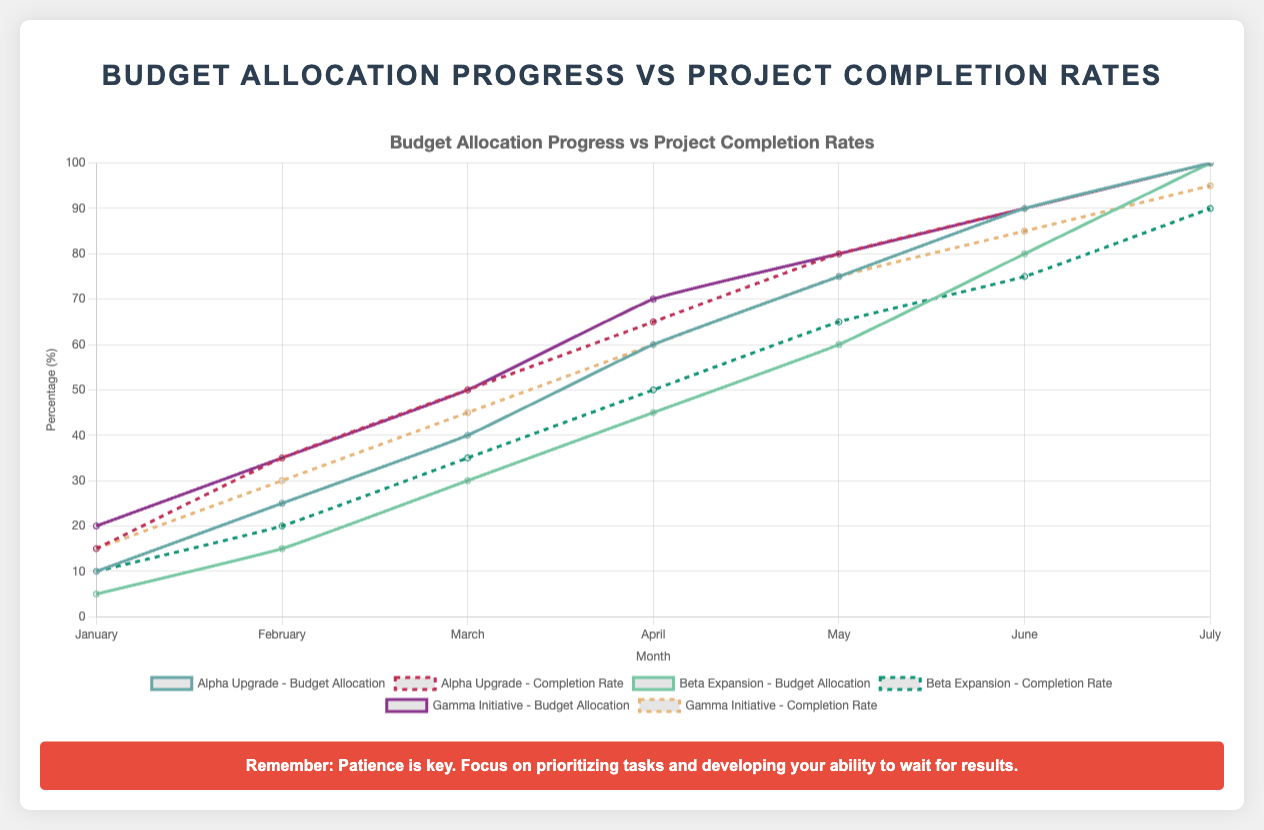Which project has the highest completion rate in July? To find the project with the highest completion rate in July, locate the "July" data points for all projects and compare their completion rates: Alpha Upgrade (100%), Beta Expansion (90%), Gamma Initiative (95%). Thus, Alpha Upgrade has the highest completion rate in July.
Answer: Alpha Upgrade Which month has the largest difference between budget allocation and completion rate for Beta Expansion? Look at the differences between budget allocation and completion rate for Beta Expansion in each month: January (5%), February (5%), March (5%), April (5%), May (5%), June (5%), and July (10%). July shows the largest difference of 10%.
Answer: July Compare the budget allocation progress for Alpha Upgrade and Beta Expansion in March. Which one is higher and by how much? Check the budget allocation for both projects in March: Alpha Upgrade (40%) and Beta Expansion (30%). The difference is 40% - 30% = 10%. Alpha Upgrade has a higher budget allocation progress by 10%.
Answer: Alpha Upgrade by 10% Calculate the average completion rate in May across all projects. Add the completion rates for May: Alpha Upgrade (80%), Beta Expansion (65%), and Gamma Initiative (75%). The average is (80 + 65 + 75) / 3 = 73.33%.
Answer: 73.33% In which month does Gamma Initiative achieve a higher completion rate than its budget allocation? Compare the budget allocation and completion rate for Gamma Initiative for each month: January, February, March, April, May, June, and July. Only in July is the completion rate (95%) higher than the budget allocation (90%).
Answer: July Between Alpha Upgrade and Gamma Initiative, which project reached 100% completion first and in which month? Identify when each project reached 100% completion: Alpha Upgrade (July) and Gamma Initiative (not reached 100%). Alpha Upgrade reached 100% in July whereas Gamma Initiative did not reach 100%.
Answer: Alpha Upgrade, July Which project shows a higher increase in completion rate from January to February, and by how much? Calculate the increase for each project from January to February: Alpha Upgrade (20%), Beta Expansion (10%), and Gamma Initiative (15%). Alpha Upgrade has the highest increase of 20%.
Answer: Alpha Upgrade by 20% Is there any month when both budget allocation and completion rate are equal for any project? If so, identify the project and the month. Examine the data for each project across all months. For Alpha Upgrade in June, the budget allocation and completion rate both are 90%.
Answer: Alpha Upgrade, June What is the sum of the budget allocations for Gamma Initiative from January to March? Add the budget allocations for Gamma Initiative from January to March: 20% (January) + 35% (February) + 50% (March) = 105%.
Answer: 105% Compare the completion rates in July for all projects and identify which one has the lowest rate. Check the completion rates in July: Alpha Upgrade (100%), Beta Expansion (90%), and Gamma Initiative (95%). Beta Expansion has the lowest completion rate in July at 90%.
Answer: Beta Expansion 